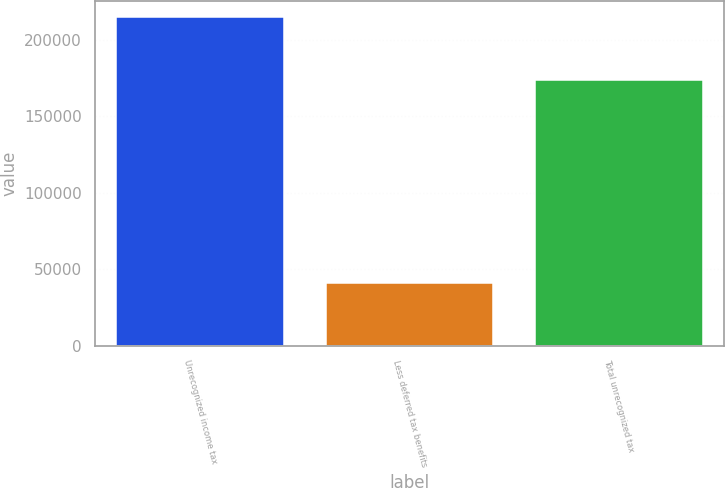Convert chart to OTSL. <chart><loc_0><loc_0><loc_500><loc_500><bar_chart><fcel>Unrecognized income tax<fcel>Less deferred tax benefits<fcel>Total unrecognized tax<nl><fcel>214790<fcel>40862<fcel>173928<nl></chart> 